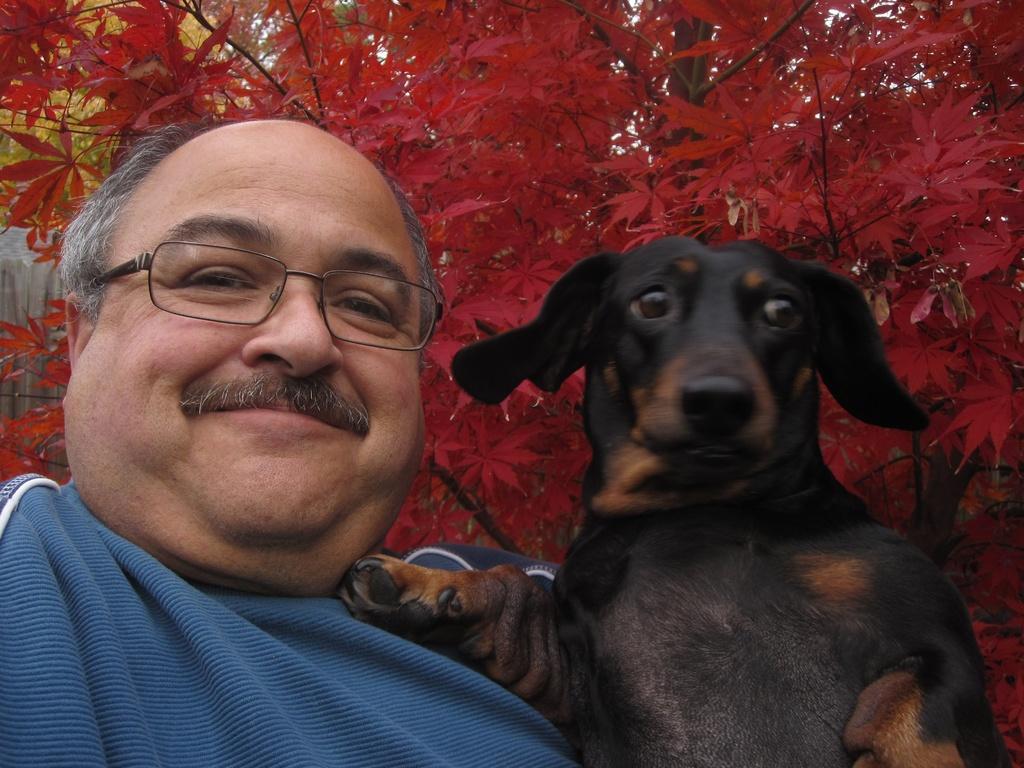Could you give a brief overview of what you see in this image? In this picture a man and a black dog are smiling. In the background there are beautiful red flowers. 